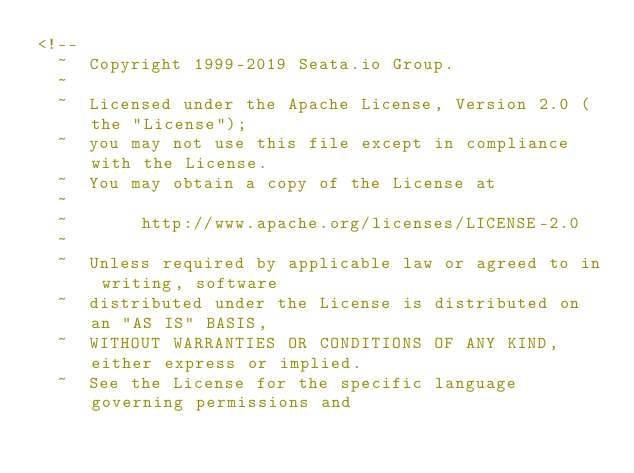Convert code to text. <code><loc_0><loc_0><loc_500><loc_500><_XML_><!--
  ~  Copyright 1999-2019 Seata.io Group.
  ~
  ~  Licensed under the Apache License, Version 2.0 (the "License");
  ~  you may not use this file except in compliance with the License.
  ~  You may obtain a copy of the License at
  ~
  ~       http://www.apache.org/licenses/LICENSE-2.0
  ~
  ~  Unless required by applicable law or agreed to in writing, software
  ~  distributed under the License is distributed on an "AS IS" BASIS,
  ~  WITHOUT WARRANTIES OR CONDITIONS OF ANY KIND, either express or implied.
  ~  See the License for the specific language governing permissions and</code> 